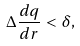<formula> <loc_0><loc_0><loc_500><loc_500>\Delta \frac { d q } { d r } < \delta ,</formula> 